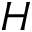<formula> <loc_0><loc_0><loc_500><loc_500>H</formula> 